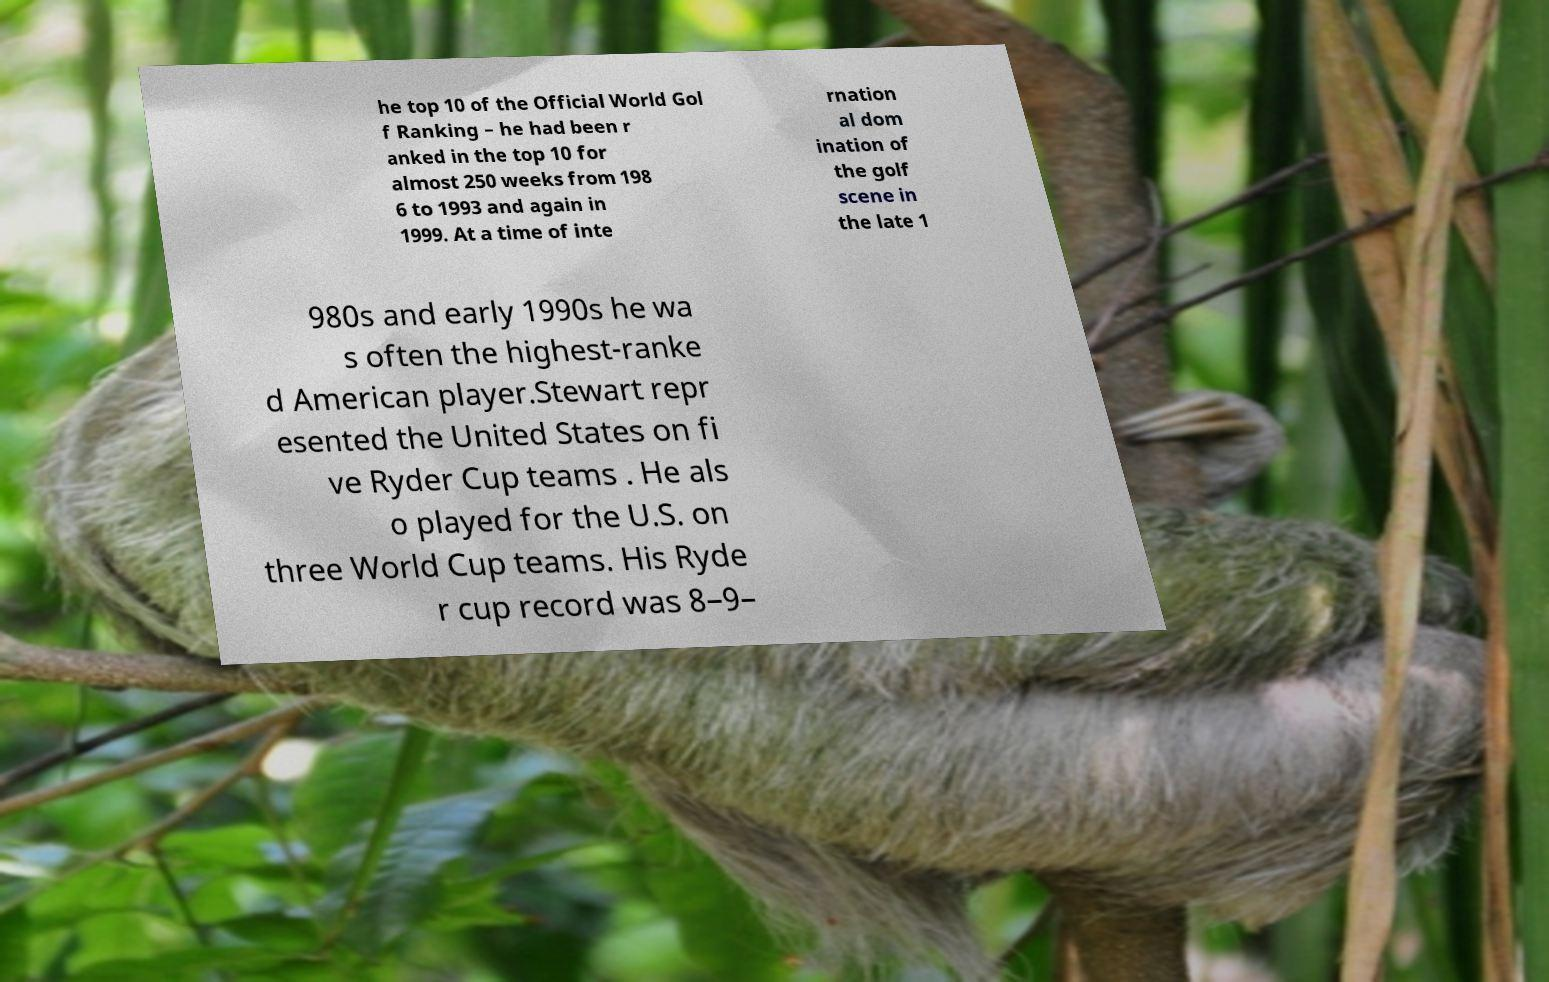Can you accurately transcribe the text from the provided image for me? he top 10 of the Official World Gol f Ranking – he had been r anked in the top 10 for almost 250 weeks from 198 6 to 1993 and again in 1999. At a time of inte rnation al dom ination of the golf scene in the late 1 980s and early 1990s he wa s often the highest-ranke d American player.Stewart repr esented the United States on fi ve Ryder Cup teams . He als o played for the U.S. on three World Cup teams. His Ryde r cup record was 8–9– 